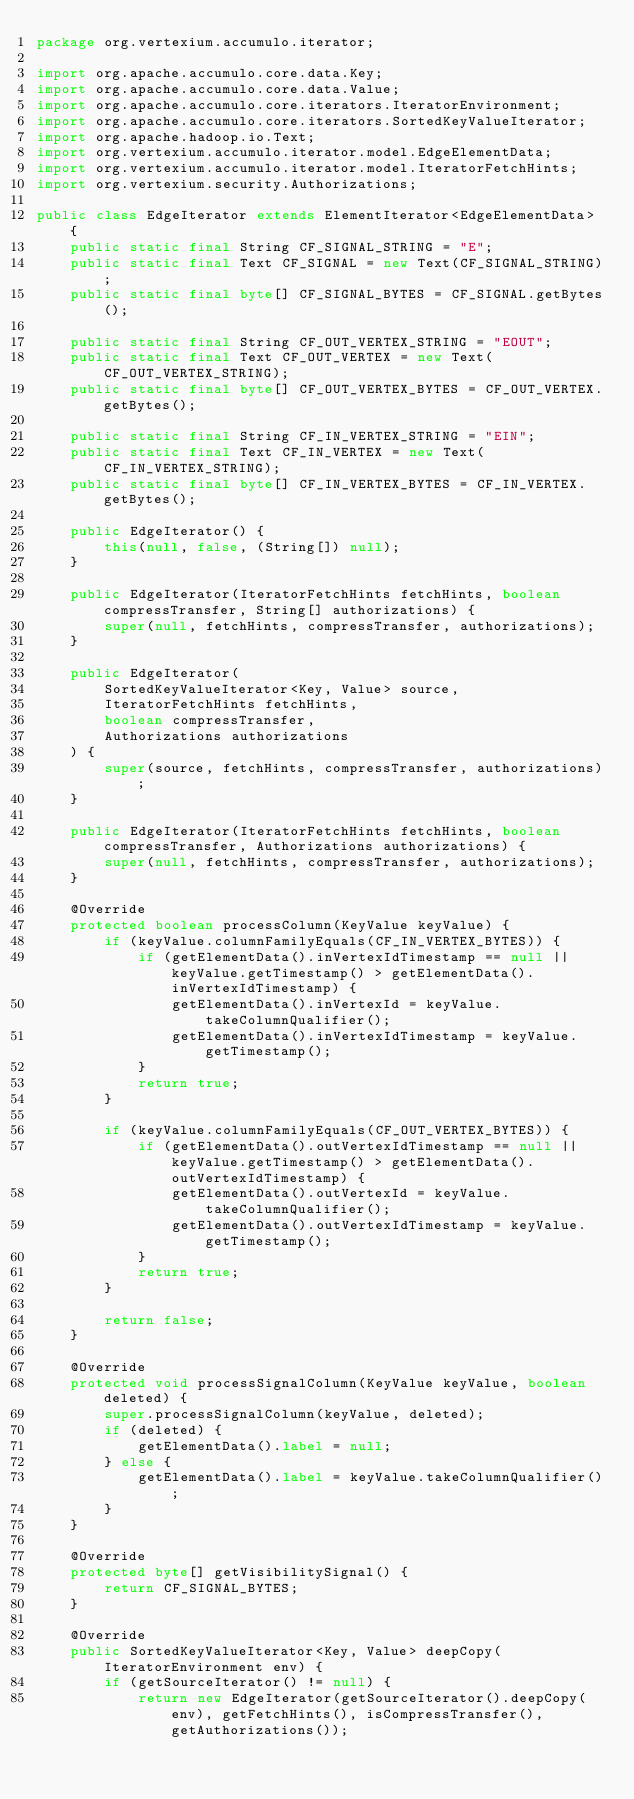Convert code to text. <code><loc_0><loc_0><loc_500><loc_500><_Java_>package org.vertexium.accumulo.iterator;

import org.apache.accumulo.core.data.Key;
import org.apache.accumulo.core.data.Value;
import org.apache.accumulo.core.iterators.IteratorEnvironment;
import org.apache.accumulo.core.iterators.SortedKeyValueIterator;
import org.apache.hadoop.io.Text;
import org.vertexium.accumulo.iterator.model.EdgeElementData;
import org.vertexium.accumulo.iterator.model.IteratorFetchHints;
import org.vertexium.security.Authorizations;

public class EdgeIterator extends ElementIterator<EdgeElementData> {
    public static final String CF_SIGNAL_STRING = "E";
    public static final Text CF_SIGNAL = new Text(CF_SIGNAL_STRING);
    public static final byte[] CF_SIGNAL_BYTES = CF_SIGNAL.getBytes();

    public static final String CF_OUT_VERTEX_STRING = "EOUT";
    public static final Text CF_OUT_VERTEX = new Text(CF_OUT_VERTEX_STRING);
    public static final byte[] CF_OUT_VERTEX_BYTES = CF_OUT_VERTEX.getBytes();

    public static final String CF_IN_VERTEX_STRING = "EIN";
    public static final Text CF_IN_VERTEX = new Text(CF_IN_VERTEX_STRING);
    public static final byte[] CF_IN_VERTEX_BYTES = CF_IN_VERTEX.getBytes();

    public EdgeIterator() {
        this(null, false, (String[]) null);
    }

    public EdgeIterator(IteratorFetchHints fetchHints, boolean compressTransfer, String[] authorizations) {
        super(null, fetchHints, compressTransfer, authorizations);
    }

    public EdgeIterator(
        SortedKeyValueIterator<Key, Value> source,
        IteratorFetchHints fetchHints,
        boolean compressTransfer,
        Authorizations authorizations
    ) {
        super(source, fetchHints, compressTransfer, authorizations);
    }

    public EdgeIterator(IteratorFetchHints fetchHints, boolean compressTransfer, Authorizations authorizations) {
        super(null, fetchHints, compressTransfer, authorizations);
    }

    @Override
    protected boolean processColumn(KeyValue keyValue) {
        if (keyValue.columnFamilyEquals(CF_IN_VERTEX_BYTES)) {
            if (getElementData().inVertexIdTimestamp == null || keyValue.getTimestamp() > getElementData().inVertexIdTimestamp) {
                getElementData().inVertexId = keyValue.takeColumnQualifier();
                getElementData().inVertexIdTimestamp = keyValue.getTimestamp();
            }
            return true;
        }

        if (keyValue.columnFamilyEquals(CF_OUT_VERTEX_BYTES)) {
            if (getElementData().outVertexIdTimestamp == null || keyValue.getTimestamp() > getElementData().outVertexIdTimestamp) {
                getElementData().outVertexId = keyValue.takeColumnQualifier();
                getElementData().outVertexIdTimestamp = keyValue.getTimestamp();
            }
            return true;
        }

        return false;
    }

    @Override
    protected void processSignalColumn(KeyValue keyValue, boolean deleted) {
        super.processSignalColumn(keyValue, deleted);
        if (deleted) {
            getElementData().label = null;
        } else {
            getElementData().label = keyValue.takeColumnQualifier();
        }
    }

    @Override
    protected byte[] getVisibilitySignal() {
        return CF_SIGNAL_BYTES;
    }

    @Override
    public SortedKeyValueIterator<Key, Value> deepCopy(IteratorEnvironment env) {
        if (getSourceIterator() != null) {
            return new EdgeIterator(getSourceIterator().deepCopy(env), getFetchHints(), isCompressTransfer(), getAuthorizations());</code> 